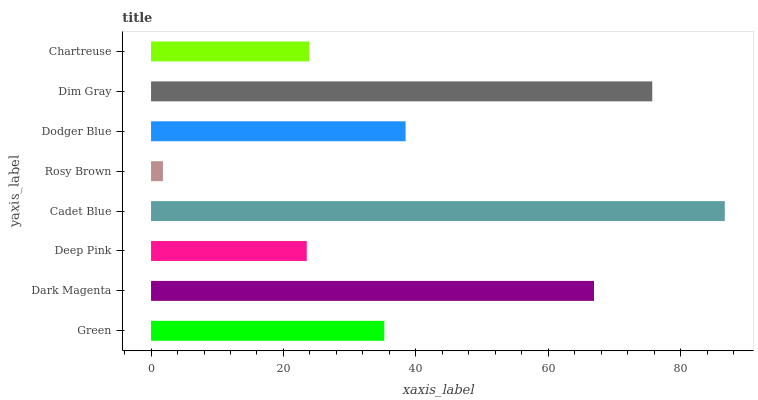Is Rosy Brown the minimum?
Answer yes or no. Yes. Is Cadet Blue the maximum?
Answer yes or no. Yes. Is Dark Magenta the minimum?
Answer yes or no. No. Is Dark Magenta the maximum?
Answer yes or no. No. Is Dark Magenta greater than Green?
Answer yes or no. Yes. Is Green less than Dark Magenta?
Answer yes or no. Yes. Is Green greater than Dark Magenta?
Answer yes or no. No. Is Dark Magenta less than Green?
Answer yes or no. No. Is Dodger Blue the high median?
Answer yes or no. Yes. Is Green the low median?
Answer yes or no. Yes. Is Dim Gray the high median?
Answer yes or no. No. Is Rosy Brown the low median?
Answer yes or no. No. 